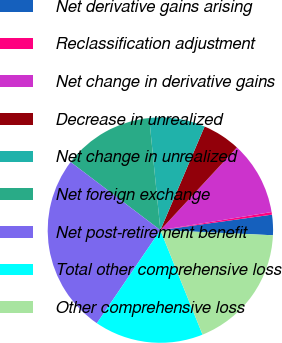Convert chart. <chart><loc_0><loc_0><loc_500><loc_500><pie_chart><fcel>Net derivative gains arising<fcel>Reclassification adjustment<fcel>Net change in derivative gains<fcel>Decrease in unrealized<fcel>Net change in unrealized<fcel>Net foreign exchange<fcel>Net post-retirement benefit<fcel>Total other comprehensive loss<fcel>Other comprehensive loss<nl><fcel>2.92%<fcel>0.37%<fcel>10.55%<fcel>5.46%<fcel>8.0%<fcel>13.09%<fcel>25.8%<fcel>15.63%<fcel>18.17%<nl></chart> 